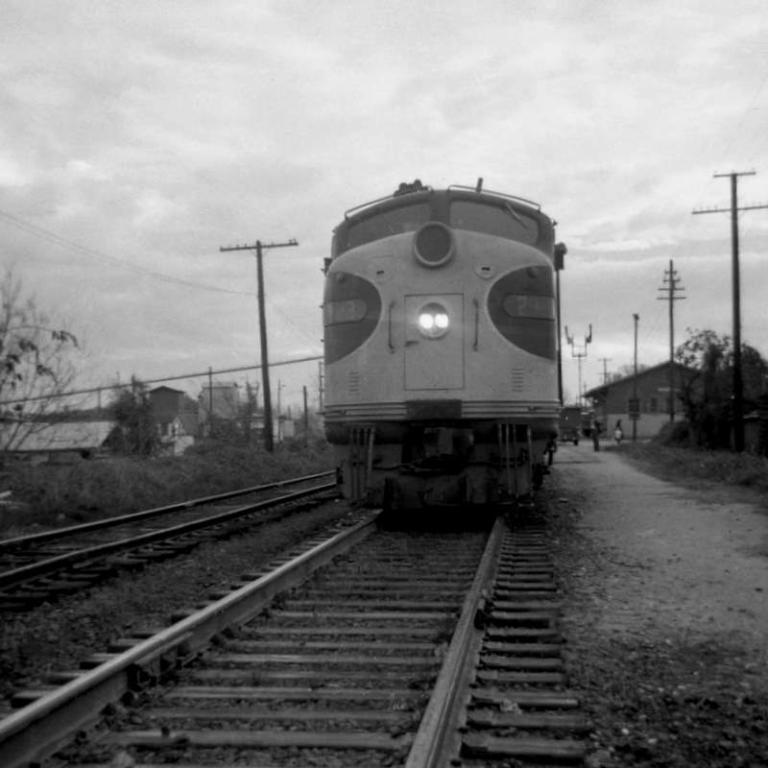Describe this image in one or two sentences. This image is taken outdoors. This image is a black and white image. At the top of the image there is the sky with clouds. At the bottom of the image there is a railway track on the ground. In the middle of the image a train is moving on the track. There are a few houses. There are a few poles with wires and street lights. 